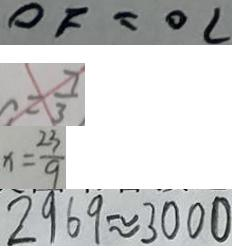<formula> <loc_0><loc_0><loc_500><loc_500>O F = O C 
 = \frac { 7 } { 3 } 
 x = \frac { 2 3 } { 9 } 
 2 9 6 9 \approx 3 0 0 0</formula> 